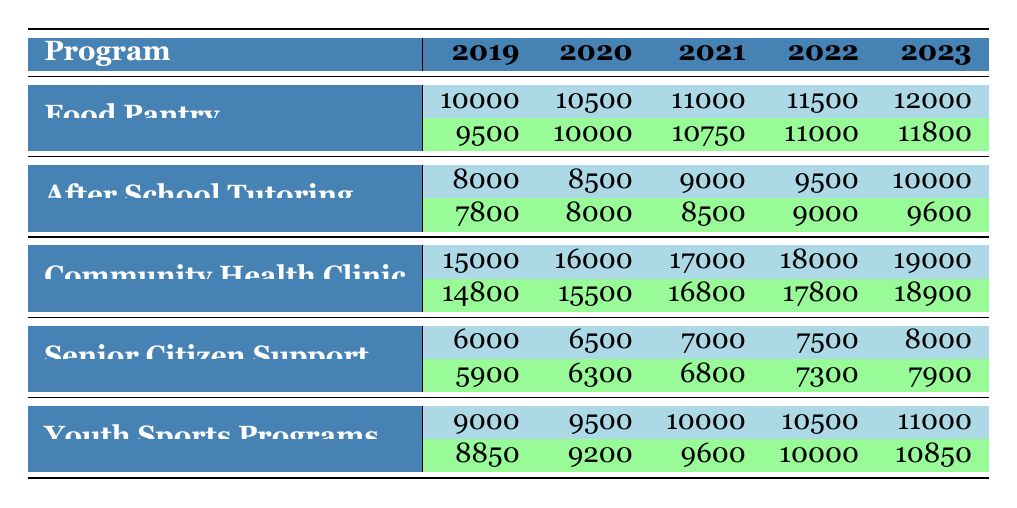What was the budget for the Food Pantry in 2022? The budget for the Food Pantry in 2022 is listed directly in the table under the 2022 column for that program, which shows 11500.
Answer: 11500 What were the expenditures for the After School Tutoring program in 2021? The expenditures for the After School Tutoring program in 2021 can be found in the table under the corresponding year, which shows 8500.
Answer: 8500 Did the Senior Citizen Support program exceed its budget in 2023? To determine if the Senior Citizen Support program exceeded its budget in 2023, we compare the budget of 8000 with its expenditures of 7900 in the same year. Since 7900 is less than 8000, the program did not exceed its budget.
Answer: No What is the total budget for the Community Health Clinic over the last 5 years? To find the total budget for the Community Health Clinic, we add the budgets from 2019 to 2023: 15000 + 16000 + 17000 + 18000 + 19000 = 85000.
Answer: 85000 What was the percentage increase in budget for Youth Sports Programs from 2019 to 2023? The budget for Youth Sports Programs in 2019 was 9000, and in 2023 it became 11000. The increase is calculated by (11000 - 9000) / 9000 * 100, which gives (2000 / 9000) * 100 ≈ 22.22 percent.
Answer: 22.22 percent In which year did the Food Pantry have the highest expenditures? From the table, we find the expenditures for the Food Pantry: 9500 in 2019, 10000 in 2020, 10750 in 2021, 11000 in 2022, and 11800 in 2023. The highest is 11800 in 2023.
Answer: 2023 Is the expenditure for the Community Health Clinic lower than its budget in all the years listed? We examine the expenditures against the budgets for each year: 14800 vs 15000 in 2019 (no), 15500 vs 16000 in 2020 (no), 16800 vs 17000 in 2021 (no), 17800 vs 18000 in 2022 (no), and 18900 vs 19000 in 2023 (no). Since there is no year where expenditures are lower, the answer is no.
Answer: No What was the average expenditure for the Youth Sports Programs over the last five years? The expenditures over the five years are 8850, 9200, 9600, 10000, and 10850. To find the average, we sum them up (8850 + 9200 + 9600 + 10000 + 10850 = 48800) and divide by 5, resulting in an average of 48800 / 5 = 9760.
Answer: 9760 